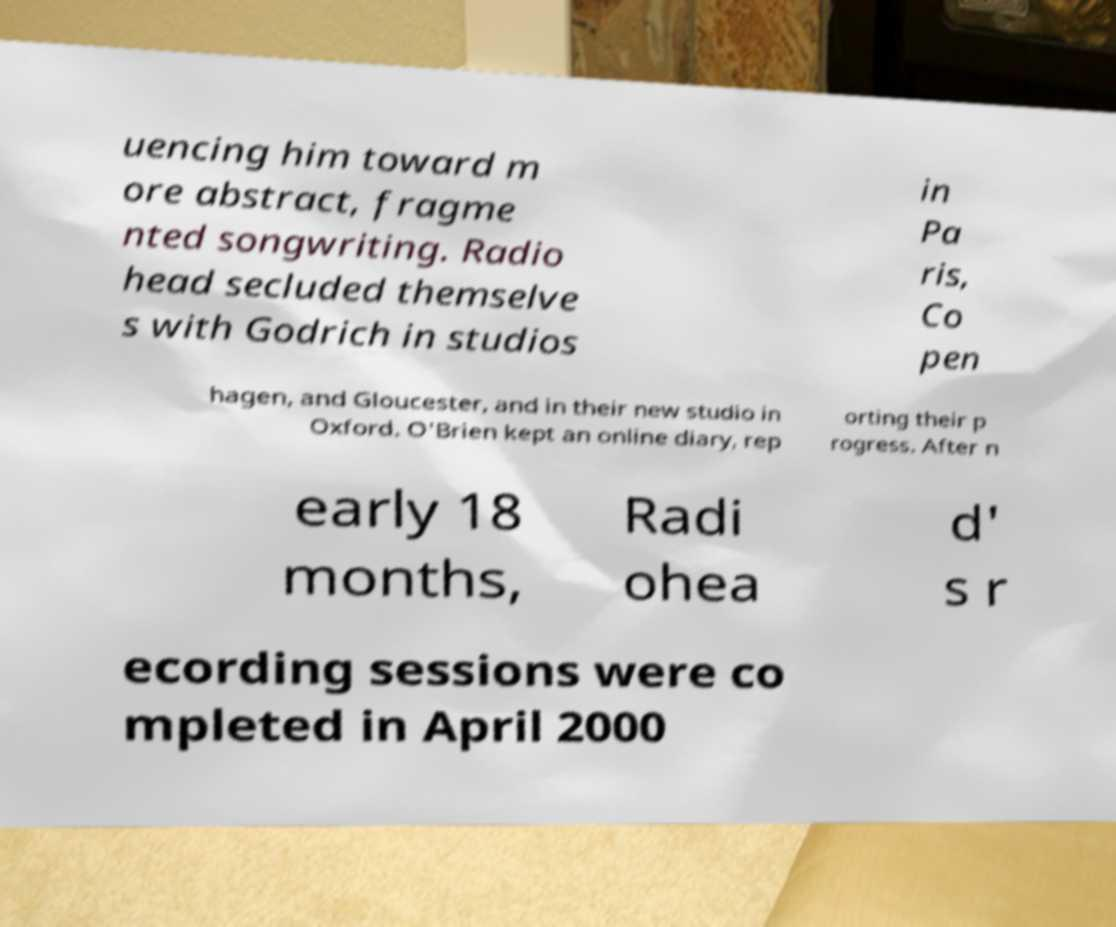There's text embedded in this image that I need extracted. Can you transcribe it verbatim? uencing him toward m ore abstract, fragme nted songwriting. Radio head secluded themselve s with Godrich in studios in Pa ris, Co pen hagen, and Gloucester, and in their new studio in Oxford. O'Brien kept an online diary, rep orting their p rogress. After n early 18 months, Radi ohea d' s r ecording sessions were co mpleted in April 2000 